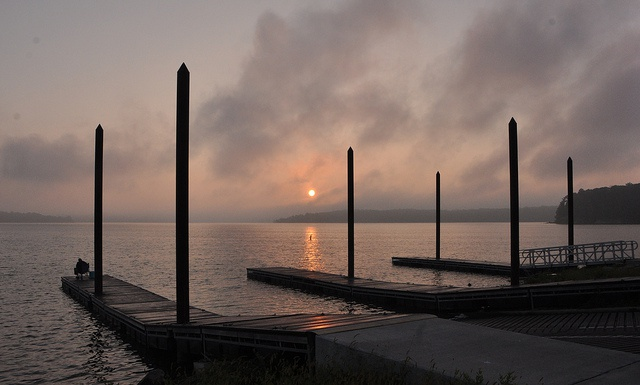Describe the objects in this image and their specific colors. I can see people in black and gray tones in this image. 